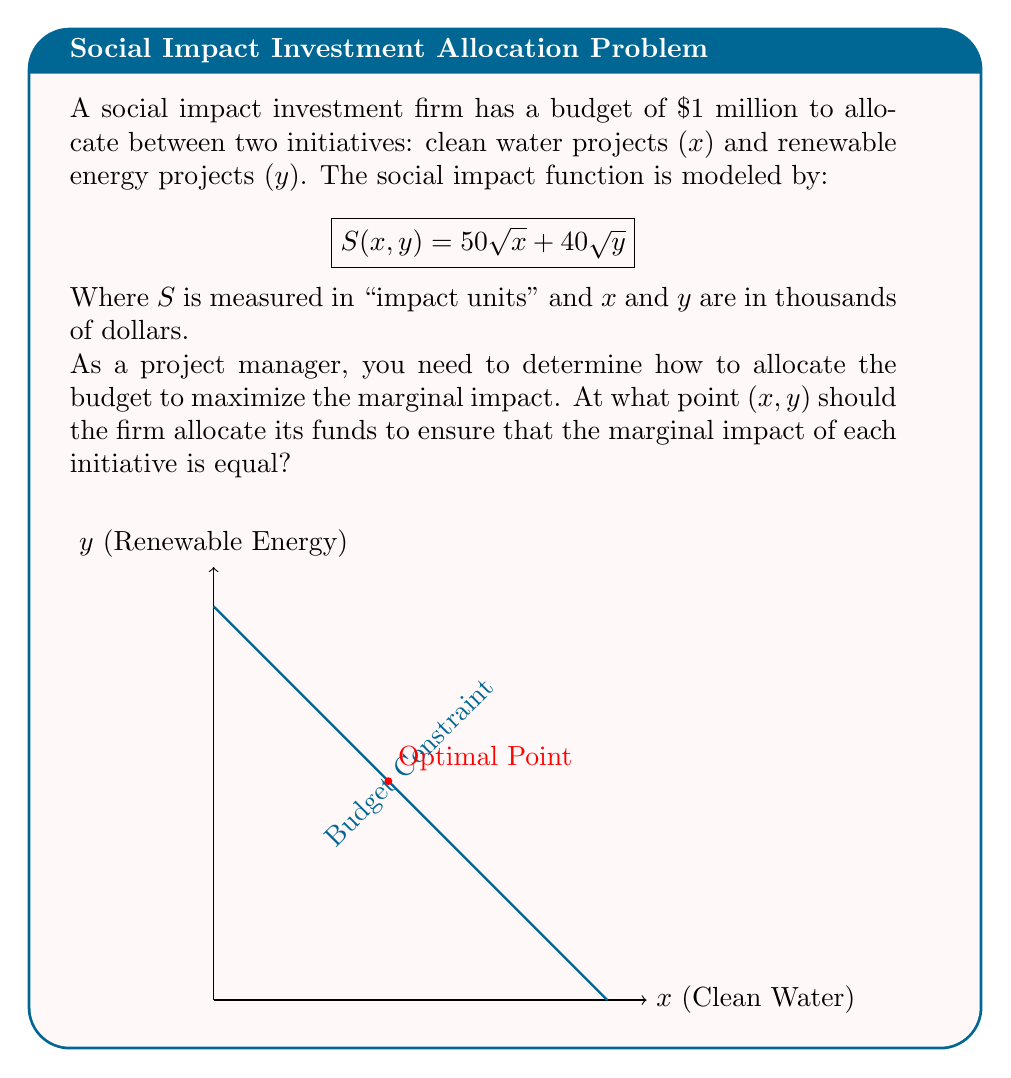Help me with this question. Let's approach this step-by-step:

1) The marginal impact for each initiative can be found by taking partial derivatives:

   $$\frac{\partial S}{\partial x} = \frac{25}{\sqrt{x}}$$ (for clean water)
   $$\frac{\partial S}{\partial y} = \frac{20}{\sqrt{y}}$$ (for renewable energy)

2) For optimal allocation, these marginal impacts should be equal:

   $$\frac{25}{\sqrt{x}} = \frac{20}{\sqrt{y}}$$

3) Cross-multiply:

   $$25\sqrt{y} = 20\sqrt{x}$$

4) Square both sides:

   $$625y = 400x$$

5) Simplify:

   $$y = \frac{16}{25}x$$

6) We also know that the total budget constraint is:

   $$x + y = 1000$$

7) Substitute the expression for y into the budget constraint:

   $$x + \frac{16}{25}x = 1000$$
   $$\frac{25x + 16x}{25} = 1000$$
   $$\frac{41x}{25} = 1000$$

8) Solve for x:

   $$x = \frac{25000}{41} \approx 609.76$$

9) Calculate y:

   $$y = 1000 - x \approx 390.24$$

10) Round to the nearest thousand dollars:

    x ≈ 610 (thousand dollars)
    y ≈ 390 (thousand dollars)

Therefore, the optimal allocation point is approximately (610, 390).
Answer: (610, 390) 